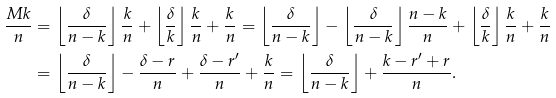Convert formula to latex. <formula><loc_0><loc_0><loc_500><loc_500>\frac { M k } { n } & = \left \lfloor \frac { \delta } { n - k } \right \rfloor \frac { k } { n } + \left \lfloor \frac { \delta } { k } \right \rfloor \frac { k } { n } + \frac { k } { n } = \left \lfloor \frac { \delta } { n - k } \right \rfloor - \left \lfloor \frac { \delta } { n - k } \right \rfloor \frac { n - k } { n } + \left \lfloor \frac { \delta } { k } \right \rfloor \frac { k } { n } + \frac { k } { n } \\ & = \left \lfloor \frac { \delta } { n - k } \right \rfloor - \frac { \delta - r } { n } + \frac { \delta - r ^ { \prime } } { n } + \frac { k } { n } = \left \lfloor \frac { \delta } { n - k } \right \rfloor + \frac { k - r ^ { \prime } + r } { n } .</formula> 